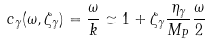<formula> <loc_0><loc_0><loc_500><loc_500>c _ { \gamma } ( \omega , \zeta _ { \gamma } ) = \frac { \omega } { k } \simeq 1 + \zeta _ { \gamma } \frac { \eta _ { \gamma } } { M _ { P } } \frac { \omega } { 2 }</formula> 